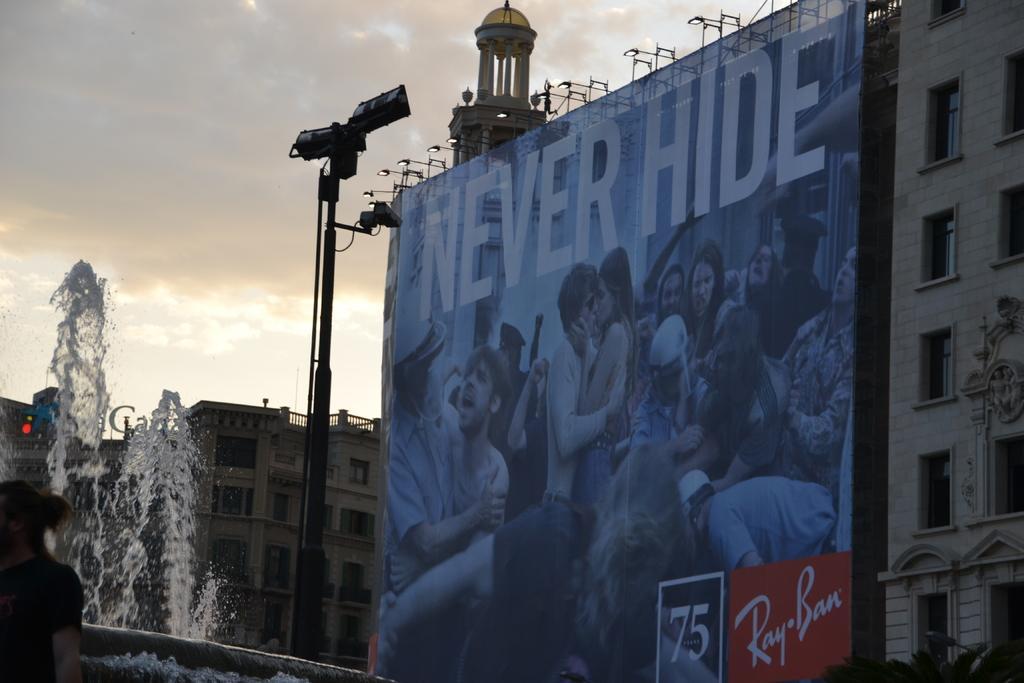Can you describe this image briefly? In this image I can see few buildings, number of windows, a poster, a pole, number of lights, a water fountain and here I can see one person. In the background I can see clouds, the sky and here on this poster I can see number of people. I can also see something is written on it. 